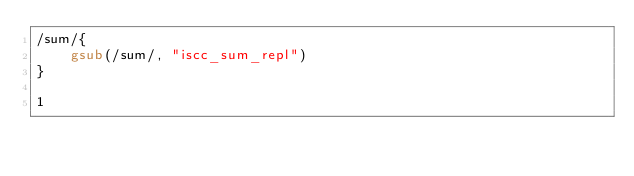<code> <loc_0><loc_0><loc_500><loc_500><_Awk_>/sum/{
	gsub(/sum/, "iscc_sum_repl")
}

1
</code> 